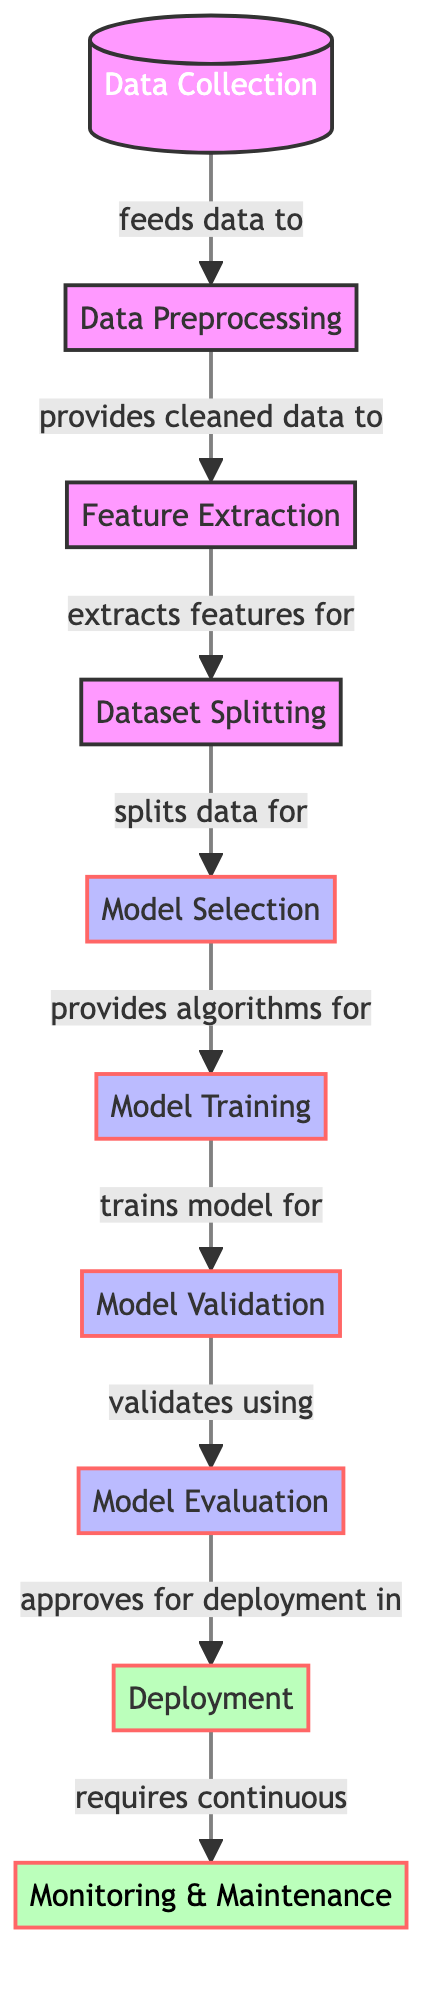What is the first step in the workflow? The first step of the workflow is indicated by the first node, which is "Data Collection." This node is where the process begins before any further actions are taken in the diagram.
Answer: Data Collection How many nodes are there in total? Counting all distinct steps represented in the diagram, there are ten nodes: Data Collection, Data Preprocessing, Feature Extraction, Dataset Splitting, Model Selection, Model Training, Model Validation, Model Evaluation, Deployment, and Monitoring & Maintenance.
Answer: Ten Which step directly provides cleaned data? The node that directly follows "Data Collection" is "Data Preprocessing," which is the step responsible for providing cleaned data to subsequent steps.
Answer: Data Preprocessing What is the final step in the machine learning workflow? The last node in the diagram, which represents the culmination of the entire workflow, is "Monitoring & Maintenance." This step ensures that the deployed model remains effective over time.
Answer: Monitoring & Maintenance Which model training step's output goes to model validation? The output from the "Model Training" node flows directly to the "Model Validation" step in the workflow, indicating a sequential relationship where validation follows training.
Answer: Model Validation What classification type do "Model Selection," "Model Training," and "Model Evaluation" belong to? These three steps are classified as processes within the diagram. They are marked distinctly to show that they involve more complex stages compared to the initial data handling steps.
Answer: Process How many types of classes are defined in this diagram? The diagram defines three distinct classes: default, process, and deploy, which categorize the workflow's nodes into visually different sections based on their roles.
Answer: Three Which node requires continuous feedback after deployment? The final node in the workflow, "Monitoring & Maintenance," indicates the need for continuous feedback post-deployment to ensure the model operates effectively in real-time scenarios.
Answer: Monitoring & Maintenance Which step is responsible for feature extraction? The "Feature Extraction" node follows "Data Preprocessing" and is responsible for extracting features necessary for the subsequent steps, particularly for model training.
Answer: Feature Extraction 